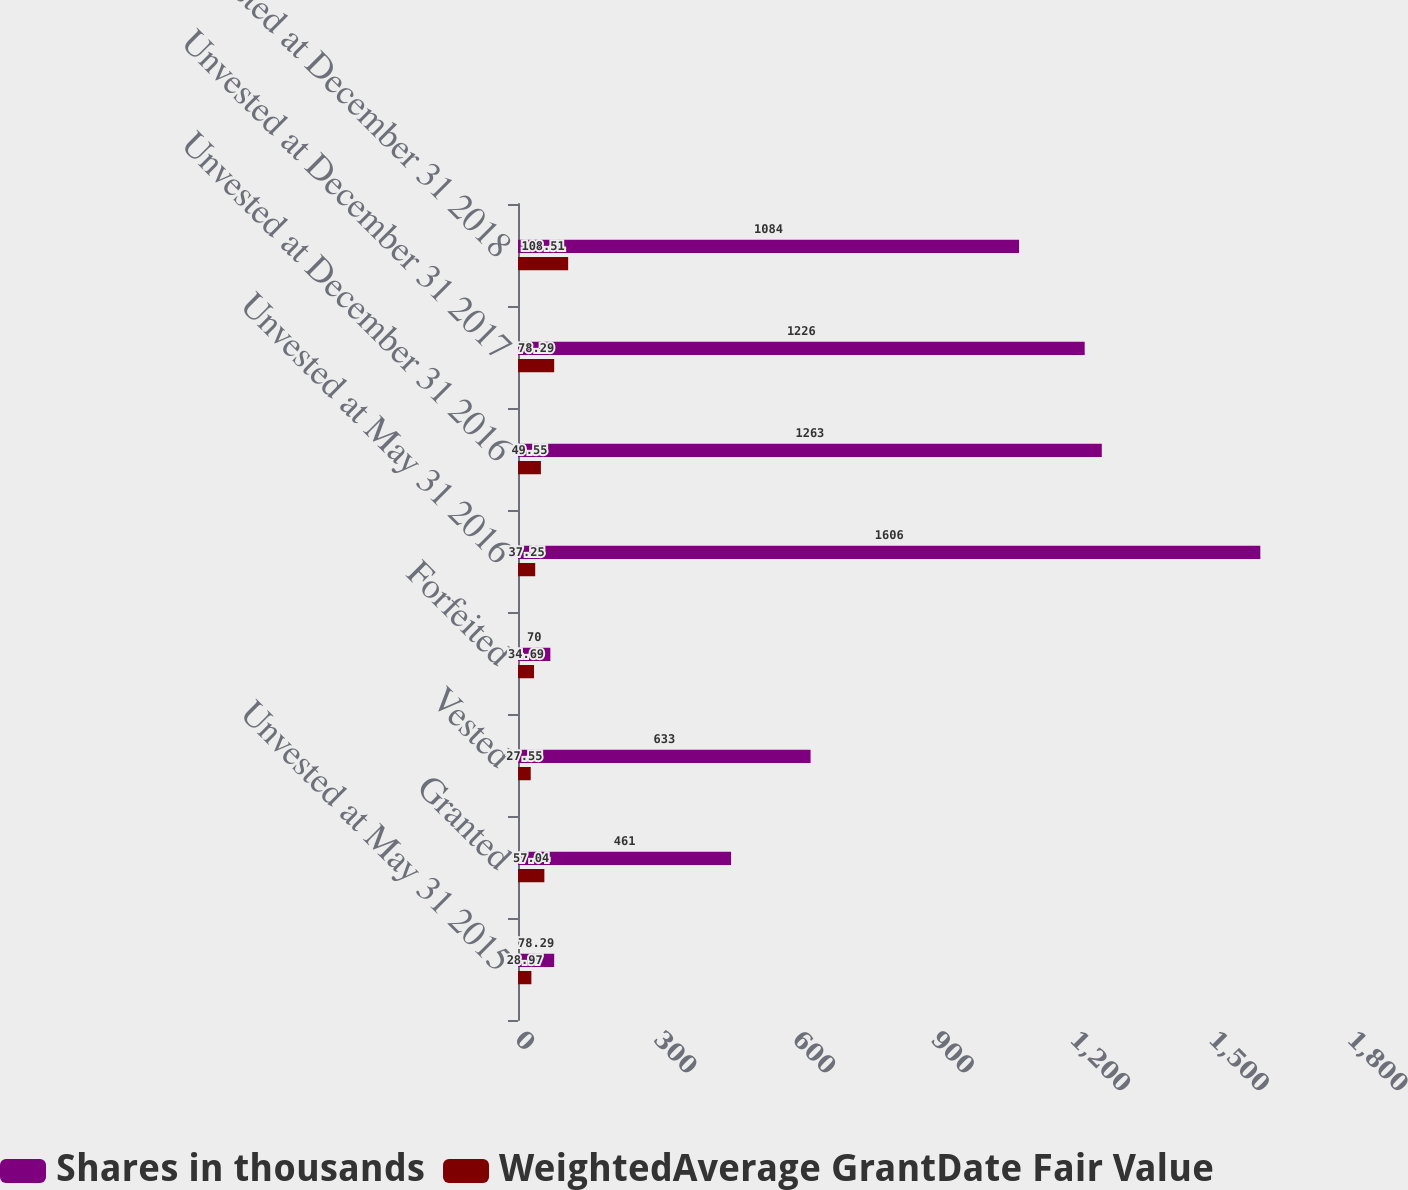Convert chart. <chart><loc_0><loc_0><loc_500><loc_500><stacked_bar_chart><ecel><fcel>Unvested at May 31 2015<fcel>Granted<fcel>Vested<fcel>Forfeited<fcel>Unvested at May 31 2016<fcel>Unvested at December 31 2016<fcel>Unvested at December 31 2017<fcel>Unvested at December 31 2018<nl><fcel>Shares in thousands<fcel>78.29<fcel>461<fcel>633<fcel>70<fcel>1606<fcel>1263<fcel>1226<fcel>1084<nl><fcel>WeightedAverage GrantDate Fair Value<fcel>28.97<fcel>57.04<fcel>27.55<fcel>34.69<fcel>37.25<fcel>49.55<fcel>78.29<fcel>108.51<nl></chart> 